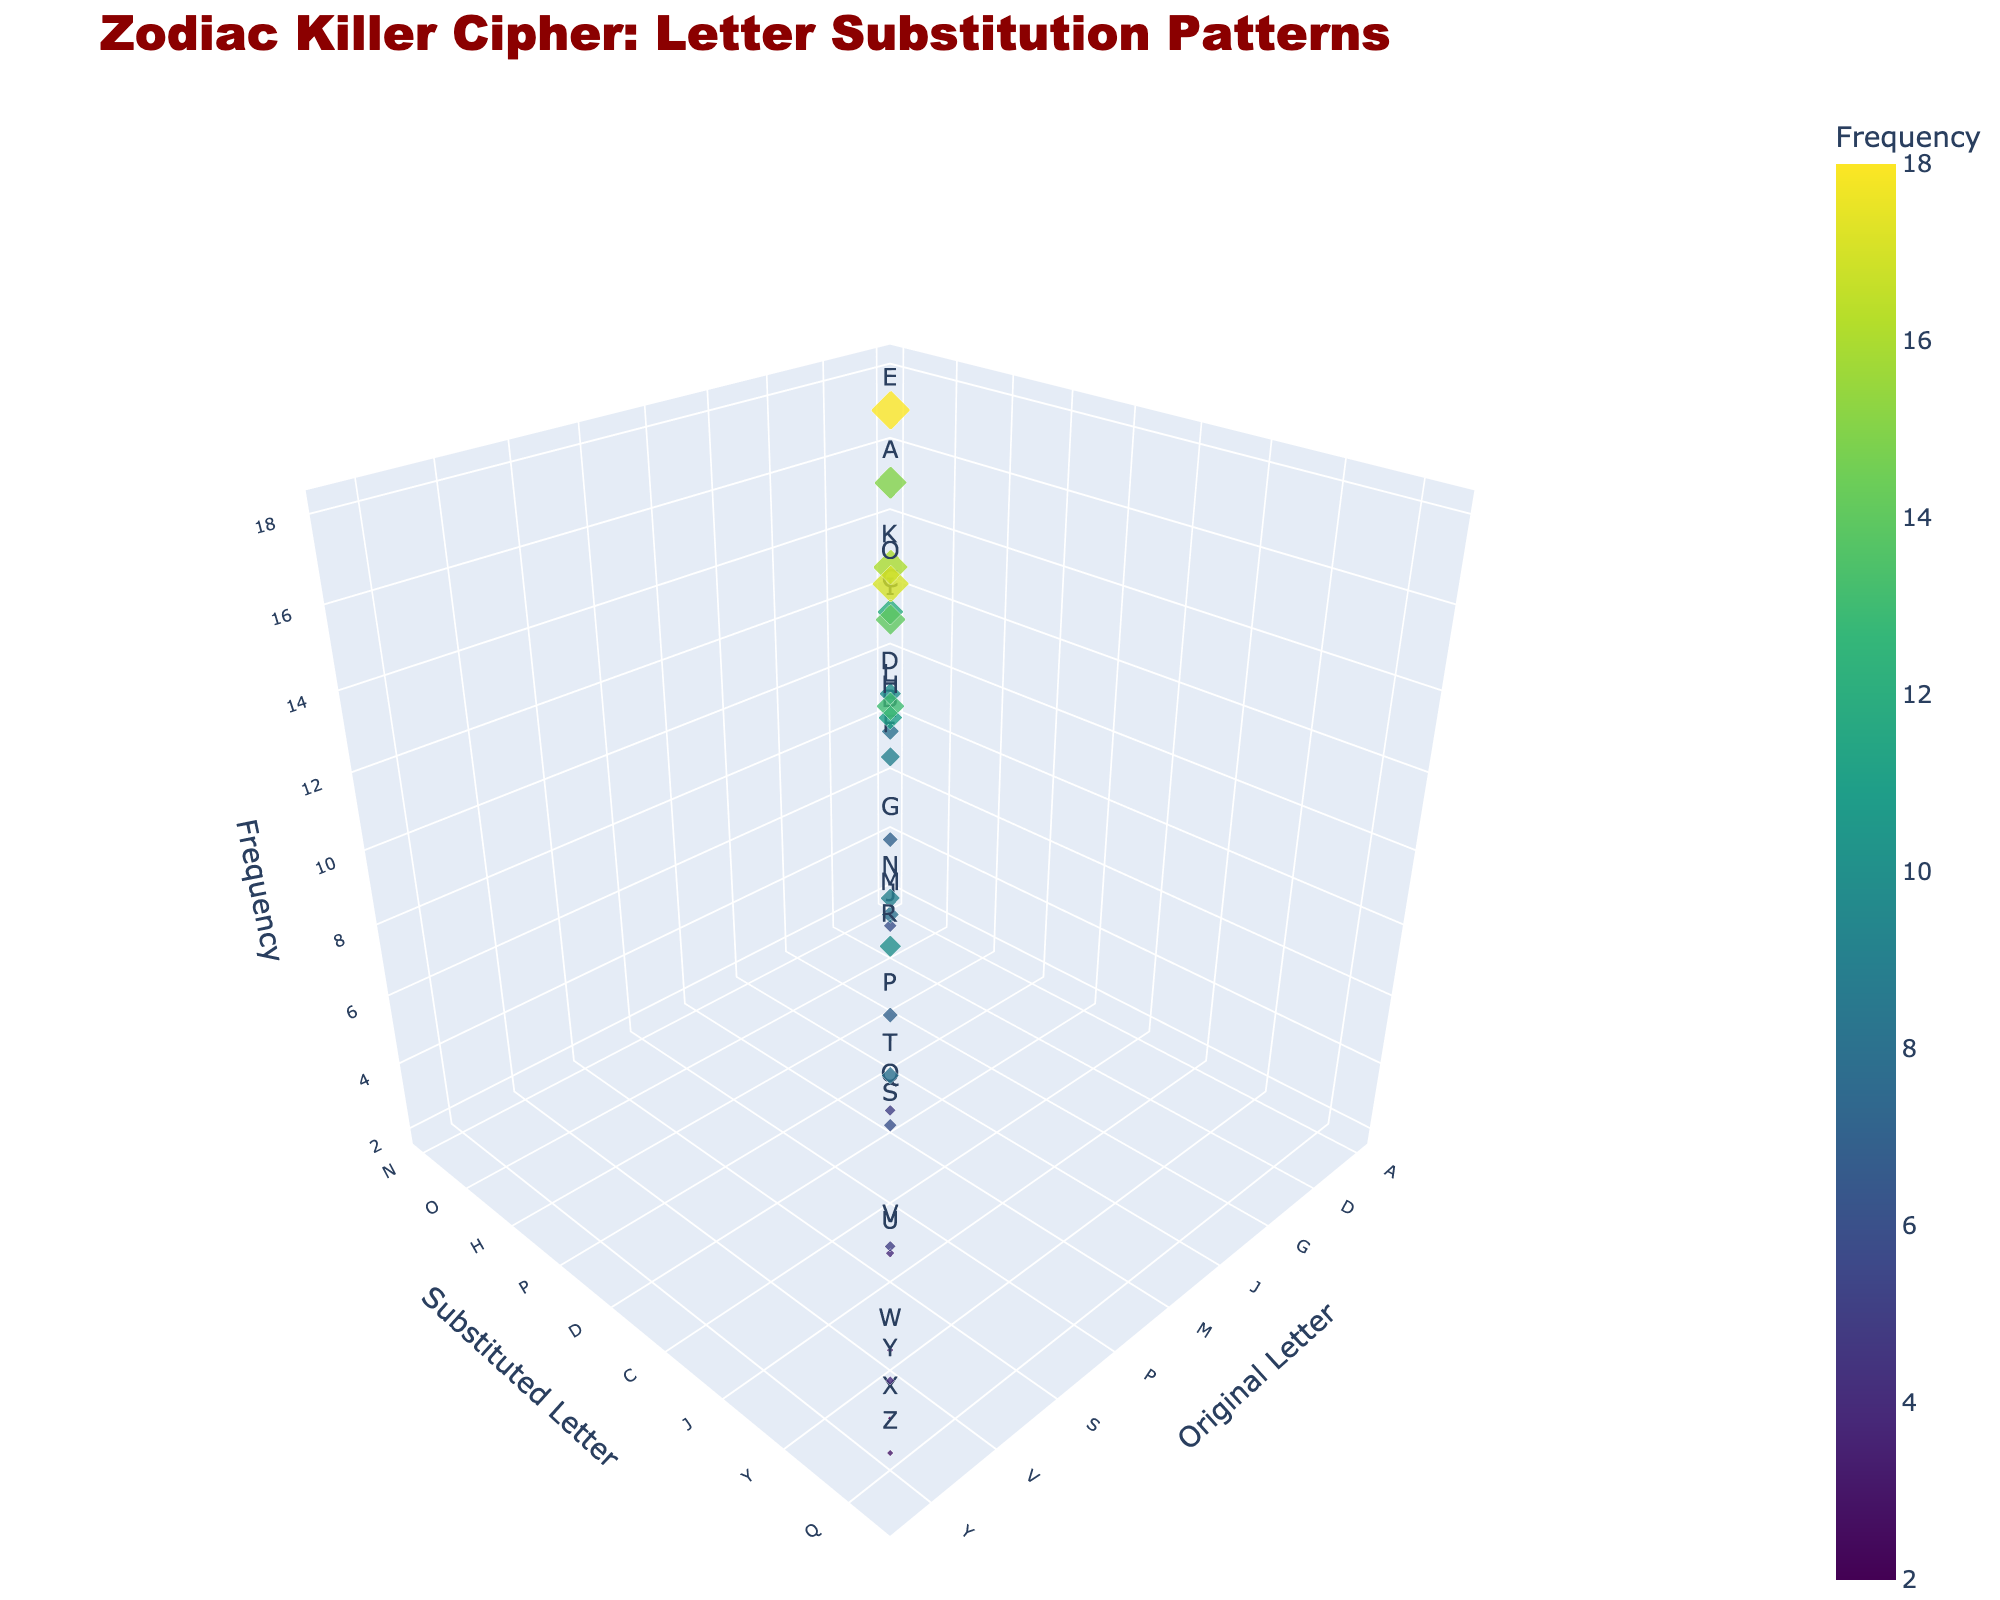what is the title of the figure? The title of the figure is the text located at the top of the plot. It describes the content or purpose of the chart. The title in this figure is "Zodiac Killer Cipher: Letter Substitution Patterns".
Answer: Zodiac Killer Cipher: Letter Substitution Patterns how many data points are represented in the plot? The number of data points can be counted by looking at the markers on the plot. Each marker represents one data point from the dataset. There are 26 letters in the dataset, and there are 26 markers in the plot.
Answer: 26 which original letter has the highest substitution frequency? To determine the letter with the highest frequency, identify the data point with the highest value on the z-axis. In this case, the letter 'E' has the highest substitution frequency of 18.
Answer: E compare the substitution frequencies of the letters 'A' and 'O'. Which one is higher? Locate the markers for original letters 'A' and 'O' and observe their z-values (frequencies). 'A' has a frequency of 15, while 'O' has a frequency of 17. Therefore, 'O' is higher.
Answer: O what is the average frequency of the substitution letters? Add up all the frequency values and divide by the number of data points. The total sum of frequencies is 248, and there are 26 letters: 248/26 = 9.54.
Answer: 9.54 which letter is substituted with the letter 'Z'? To find which letter is substituted with 'Z', locate the marker on the y-axis corresponding to 'Z'. The original letter 'X' is substituted with 'Z'.
Answer: X find the range of substitution frequencies shown in the plot. The range is the difference between the maximum and minimum values of the z-axis (frequencies). The maximum frequency is 18, and the minimum frequency is 2. The range is 18 - 2 = 16.
Answer: 16 which two letters have the same substitution frequency? Locate the markers with the same z-values (frequencies). Two pairs of letters with the same frequency are 'F' and 'N' (both have a frequency of 9) and 'J' and 'S' (both have a frequency of 6).
Answer: F, N what is the color of the marker corresponding to the letter with the lowest substitution frequency? Find the data point with the lowest z-value (frequency = 2), which is for the letter 'X'. The color of the marker is on the lower end of the Viridis color scale, likely a dark purple.
Answer: dark purple how many letters have a substitution frequency greater than 10? Count the number of markers where the z-value (frequency) is greater than 10. These letters are 'A', 'C', 'D', 'E', 'H', 'I', 'K', 'L', 'O', and 'R', totaling 10 letters.
Answer: 10 